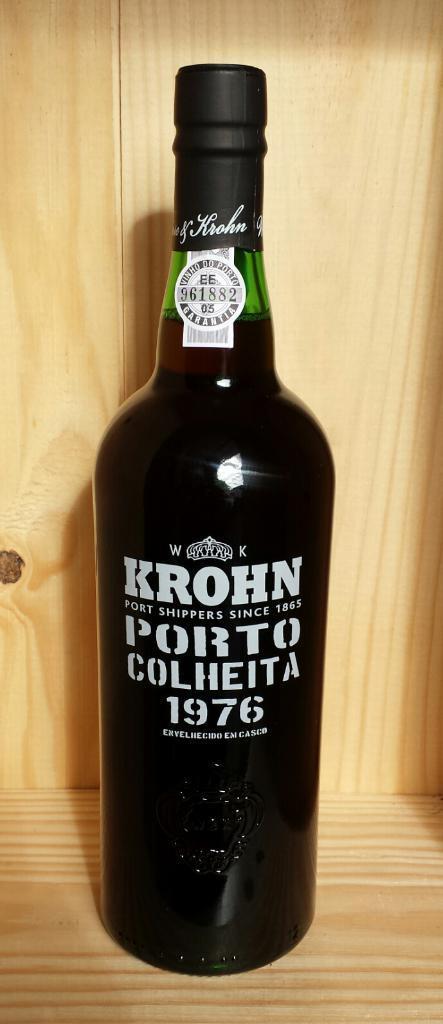How would you summarize this image in a sentence or two? In this image i can see a black color bottle. 